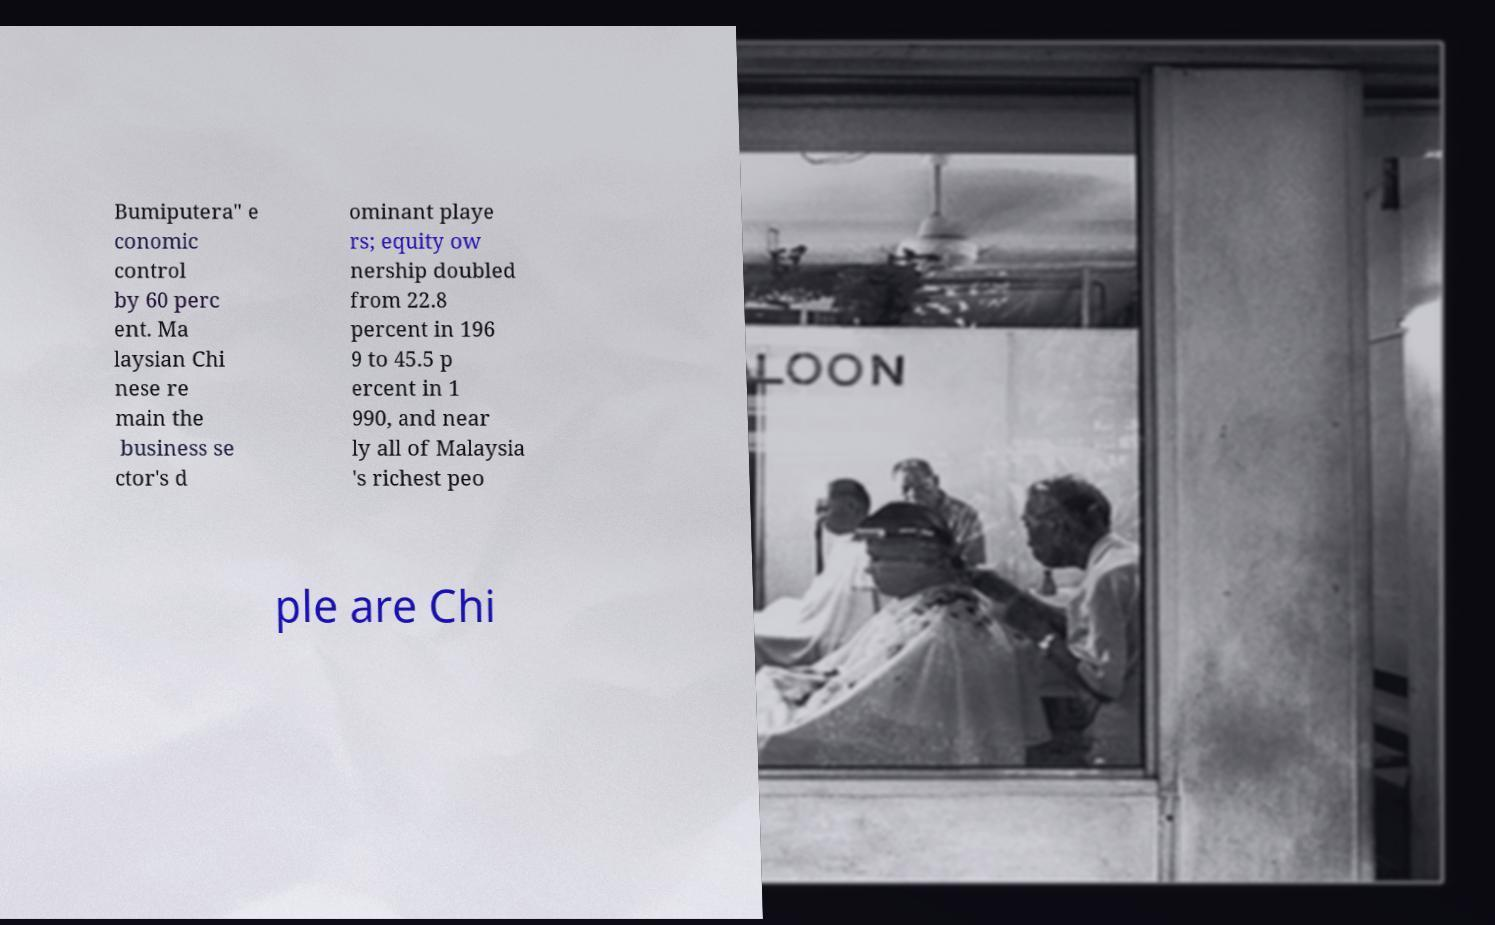Could you assist in decoding the text presented in this image and type it out clearly? Bumiputera" e conomic control by 60 perc ent. Ma laysian Chi nese re main the business se ctor's d ominant playe rs; equity ow nership doubled from 22.8 percent in 196 9 to 45.5 p ercent in 1 990, and near ly all of Malaysia 's richest peo ple are Chi 